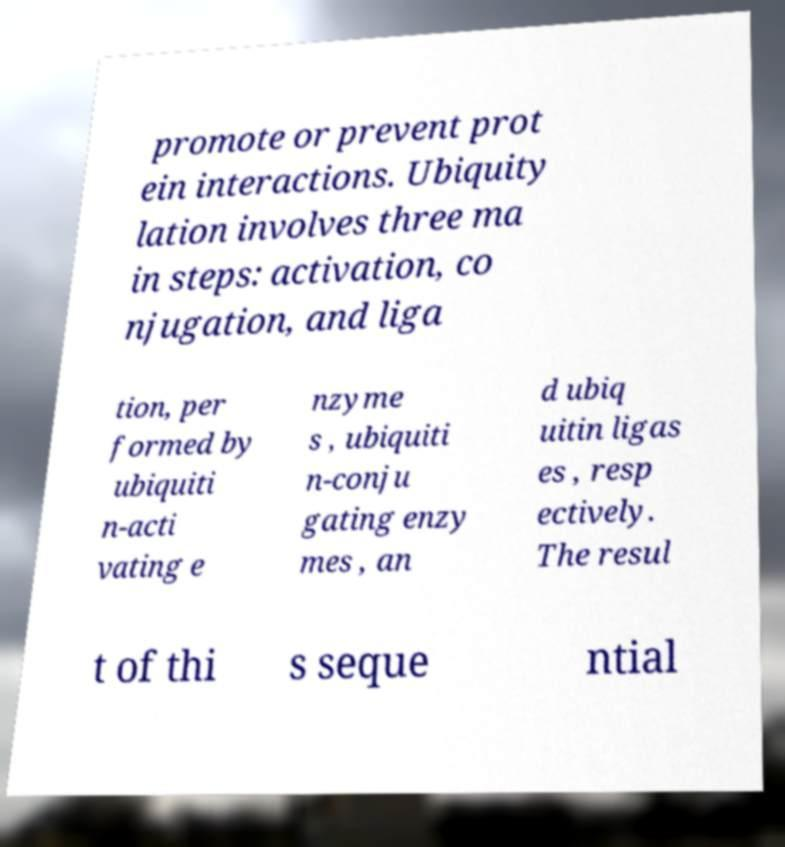I need the written content from this picture converted into text. Can you do that? promote or prevent prot ein interactions. Ubiquity lation involves three ma in steps: activation, co njugation, and liga tion, per formed by ubiquiti n-acti vating e nzyme s , ubiquiti n-conju gating enzy mes , an d ubiq uitin ligas es , resp ectively. The resul t of thi s seque ntial 